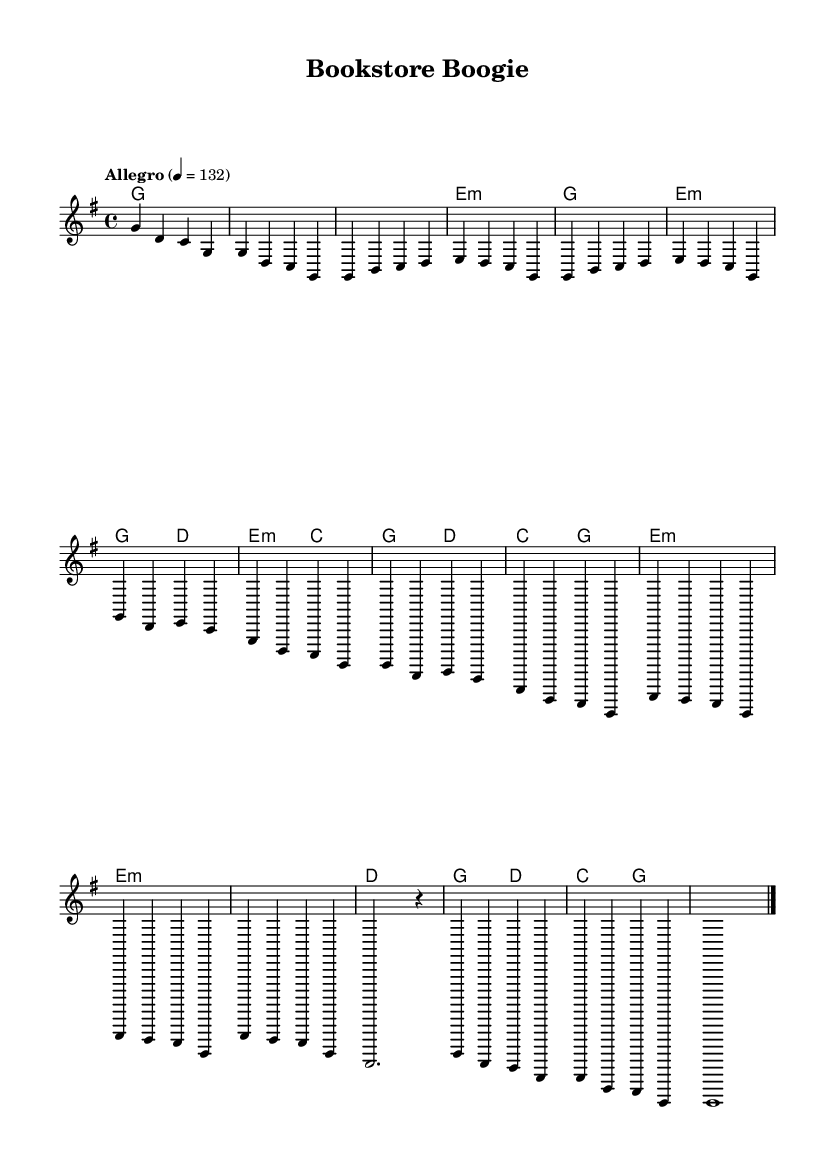What is the key signature of this music? The key signature is G major, which has one sharp (F#).
Answer: G major What is the time signature of this music? The time signature at the beginning is 4/4, indicating four beats per measure.
Answer: 4/4 What is the tempo marking for this piece? The tempo marking indicates "Allegro" at a speed of 132 beats per minute.
Answer: Allegro How many measures are in the verse section? By counting the measures in the verse section, there are a total of 8 measures.
Answer: 8 What chord is played in the intro? The chord played in the intro is G major, as indicated in the harmonies.
Answer: G Does the chorus have a repeated pattern? Yes, the chorus repeats the first two measures again, creating a familiar motif.
Answer: Yes Which lyrical theme is most likely celebrated in this piece? The piece likely celebrates small-town literary scenes, reflected in the upbeat country rock style and joyous melody.
Answer: Small-town literary scenes 